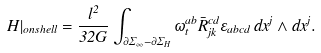Convert formula to latex. <formula><loc_0><loc_0><loc_500><loc_500>H | _ { o n s h e l l } = \frac { l ^ { 2 } } { 3 2 G } \int _ { \partial \Sigma _ { \infty } - \partial \Sigma _ { H } } \omega ^ { a b } _ { t } \bar { R } ^ { c d } _ { j k } \varepsilon _ { a b c d } \, d x ^ { j } \wedge d x ^ { j } .</formula> 